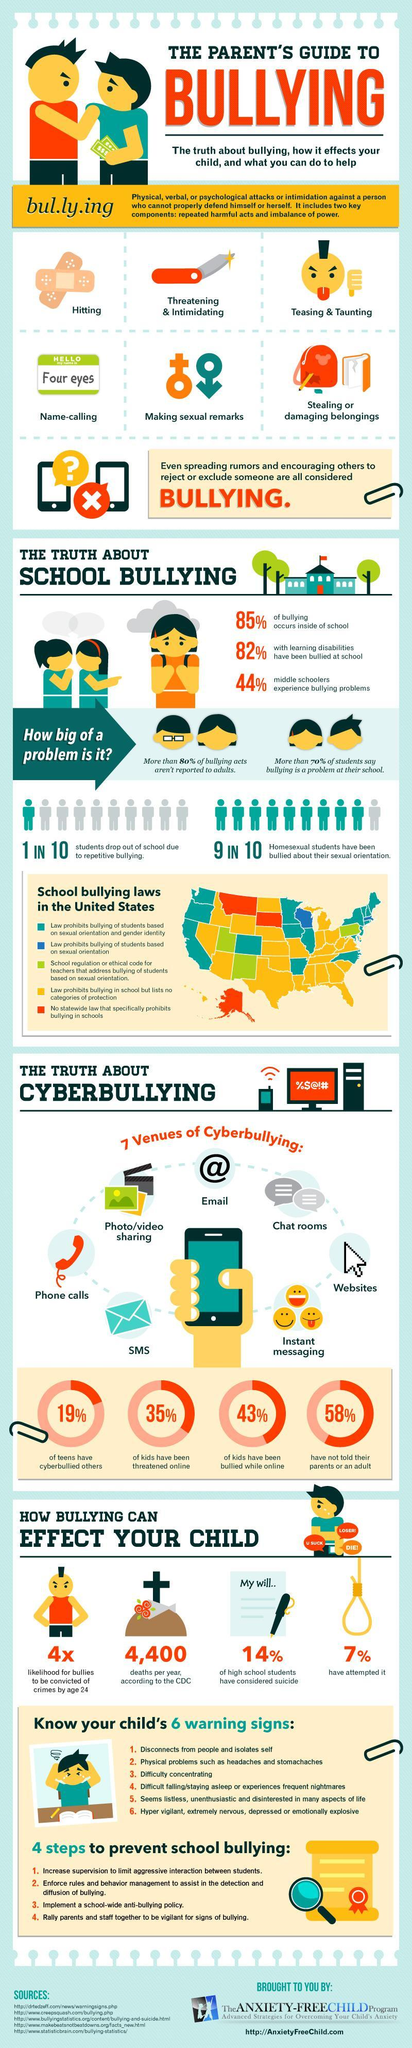What is the likelihood for bullies to be convicted of crimes by age 24 in the U.S.?
Answer the question with a short phrase. 4x What is the number of deaths of children  per year as a result of bullying in the U.S., according to the CDC? 4,400 What percentage of teens have cyberbullied others in the U.S.? 19% What percentage of kids have been bullied while online in the U.S.? 43% What percentage of children have attempted suicide as a result of bullying in the U.S.? 7% 